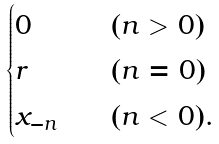Convert formula to latex. <formula><loc_0><loc_0><loc_500><loc_500>\begin{cases} 0 & \quad ( n > 0 ) \\ r & \quad ( n = 0 ) \\ x _ { - n } & \quad ( n < 0 ) . \end{cases}</formula> 